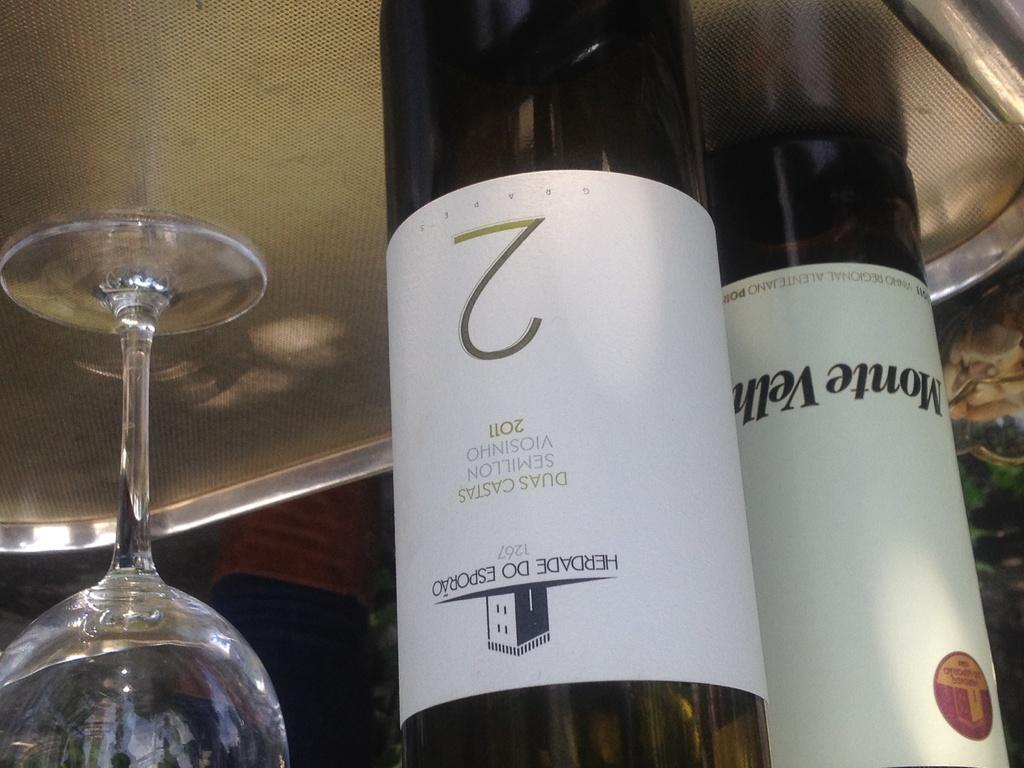<image>
Provide a brief description of the given image. A bottle has the year 2011 and a large number two on the label. 